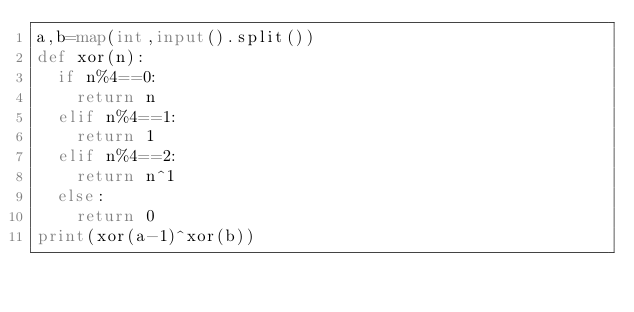<code> <loc_0><loc_0><loc_500><loc_500><_Python_>a,b=map(int,input().split())
def xor(n):
  if n%4==0:
    return n
  elif n%4==1:
    return 1
  elif n%4==2:
    return n^1
  else:
    return 0
print(xor(a-1)^xor(b))</code> 